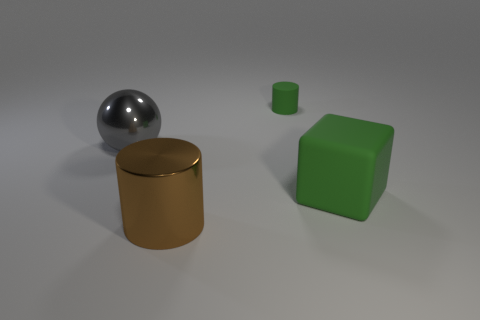Add 2 matte objects. How many objects exist? 6 Subtract all green cylinders. How many cylinders are left? 1 Subtract 1 gray spheres. How many objects are left? 3 Subtract all spheres. How many objects are left? 3 Subtract 1 spheres. How many spheres are left? 0 Subtract all green spheres. Subtract all purple blocks. How many spheres are left? 1 Subtract all green cylinders. How many yellow spheres are left? 0 Subtract all brown cylinders. Subtract all large metallic cylinders. How many objects are left? 2 Add 3 large gray spheres. How many large gray spheres are left? 4 Add 3 tiny green metal blocks. How many tiny green metal blocks exist? 3 